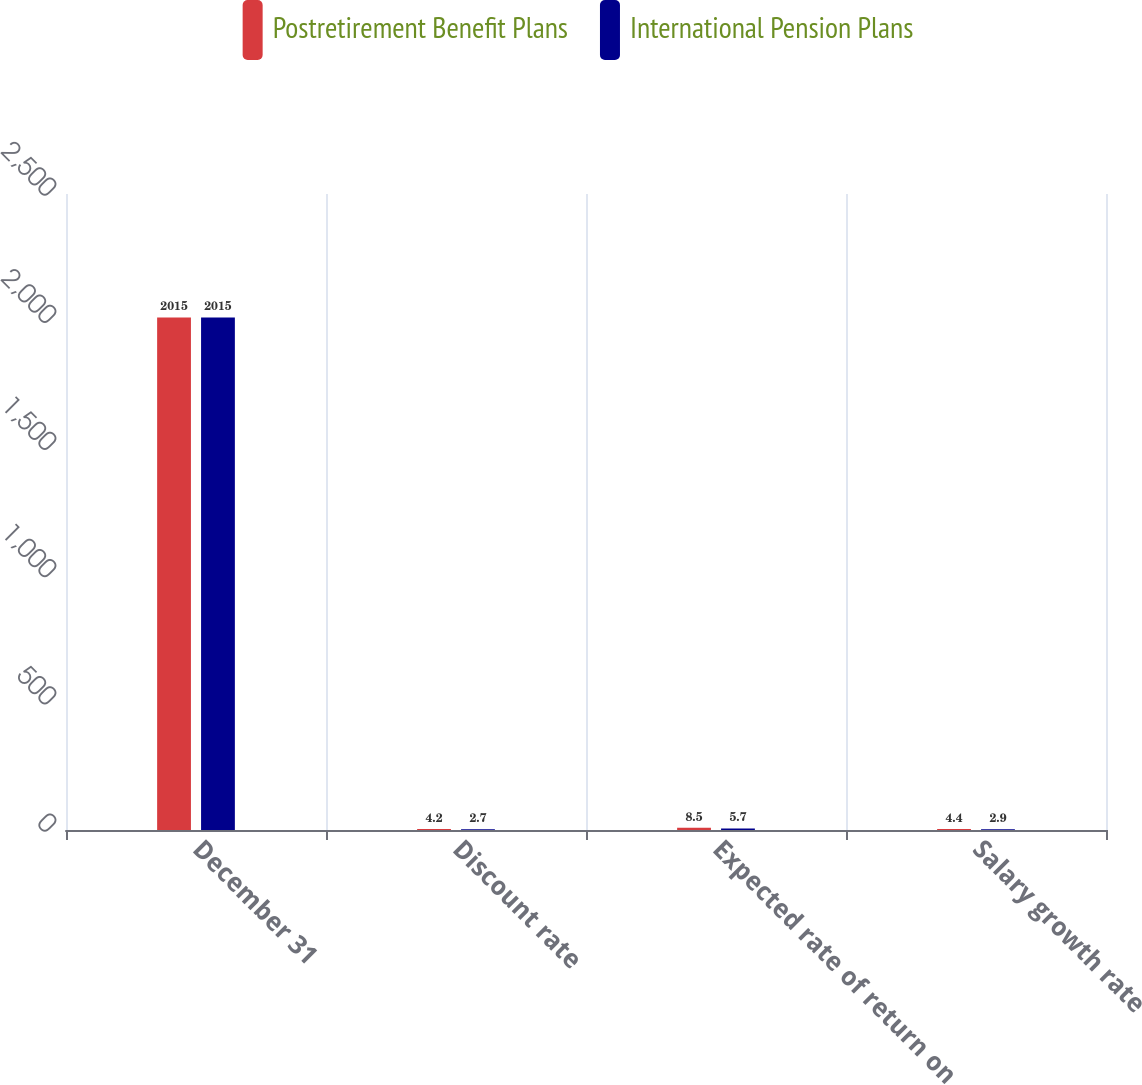<chart> <loc_0><loc_0><loc_500><loc_500><stacked_bar_chart><ecel><fcel>December 31<fcel>Discount rate<fcel>Expected rate of return on<fcel>Salary growth rate<nl><fcel>Postretirement Benefit Plans<fcel>2015<fcel>4.2<fcel>8.5<fcel>4.4<nl><fcel>International Pension Plans<fcel>2015<fcel>2.7<fcel>5.7<fcel>2.9<nl></chart> 